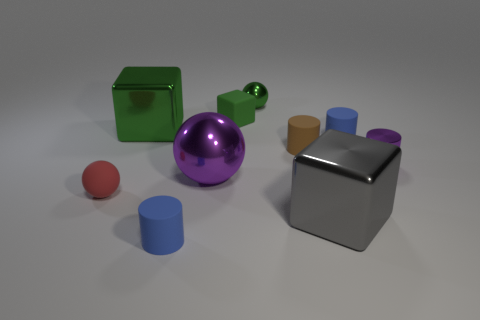Subtract 1 cylinders. How many cylinders are left? 3 Subtract all cubes. How many objects are left? 7 Subtract all small red metallic cylinders. Subtract all rubber objects. How many objects are left? 5 Add 6 tiny green objects. How many tiny green objects are left? 8 Add 3 red balls. How many red balls exist? 4 Subtract 0 brown blocks. How many objects are left? 10 